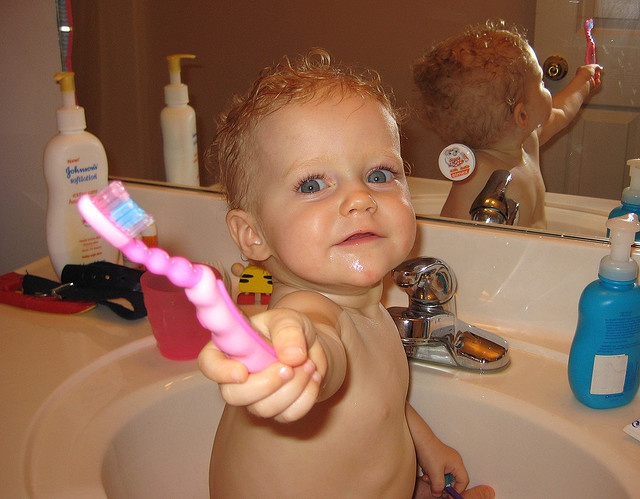Describe the objects in this image and their specific colors. I can see people in maroon, gray, tan, and brown tones, sink in maroon, tan, and gray tones, people in maroon, brown, and gray tones, toothbrush in maroon, violet, pink, and lightpink tones, and cup in maroon and brown tones in this image. 